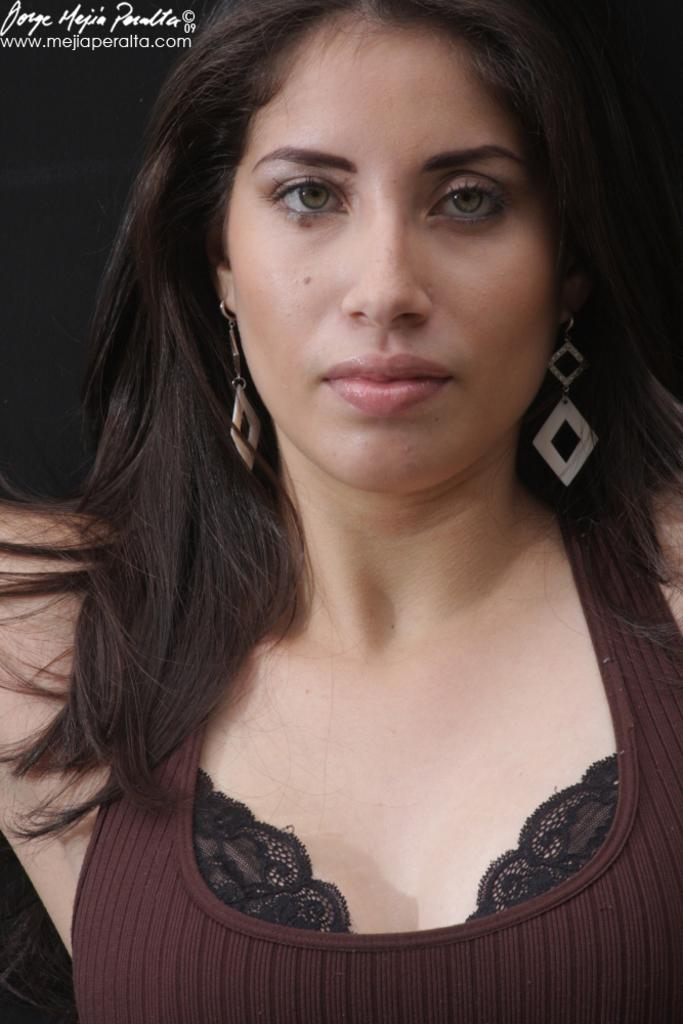Who is present in the image? There is a lady in the image. What thoughts can be seen on the lady's face in the image? The image does not show the lady's thoughts or emotions, only her physical appearance. Where is the seashore in the image? There is no seashore present in the image; it only features a lady. What type of vessel is being used by the lady in the image? There is no vessel present in the image; it only features a lady. 